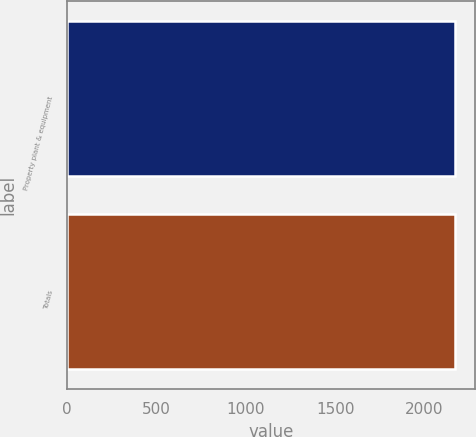<chart> <loc_0><loc_0><loc_500><loc_500><bar_chart><fcel>Property plant & equipment<fcel>Totals<nl><fcel>2172<fcel>2172.1<nl></chart> 